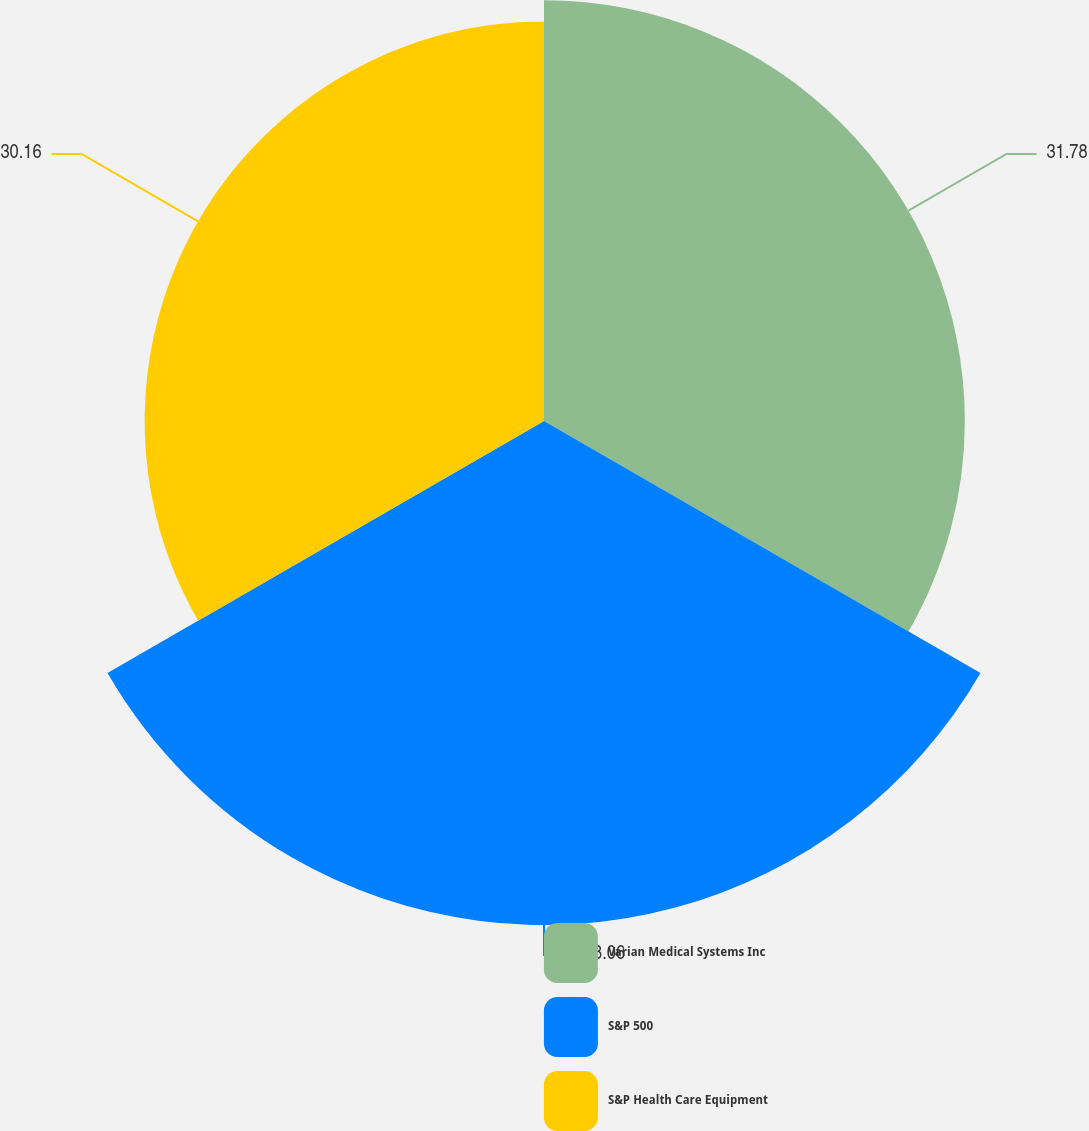<chart> <loc_0><loc_0><loc_500><loc_500><pie_chart><fcel>Varian Medical Systems Inc<fcel>S&P 500<fcel>S&P Health Care Equipment<nl><fcel>31.78%<fcel>38.06%<fcel>30.16%<nl></chart> 